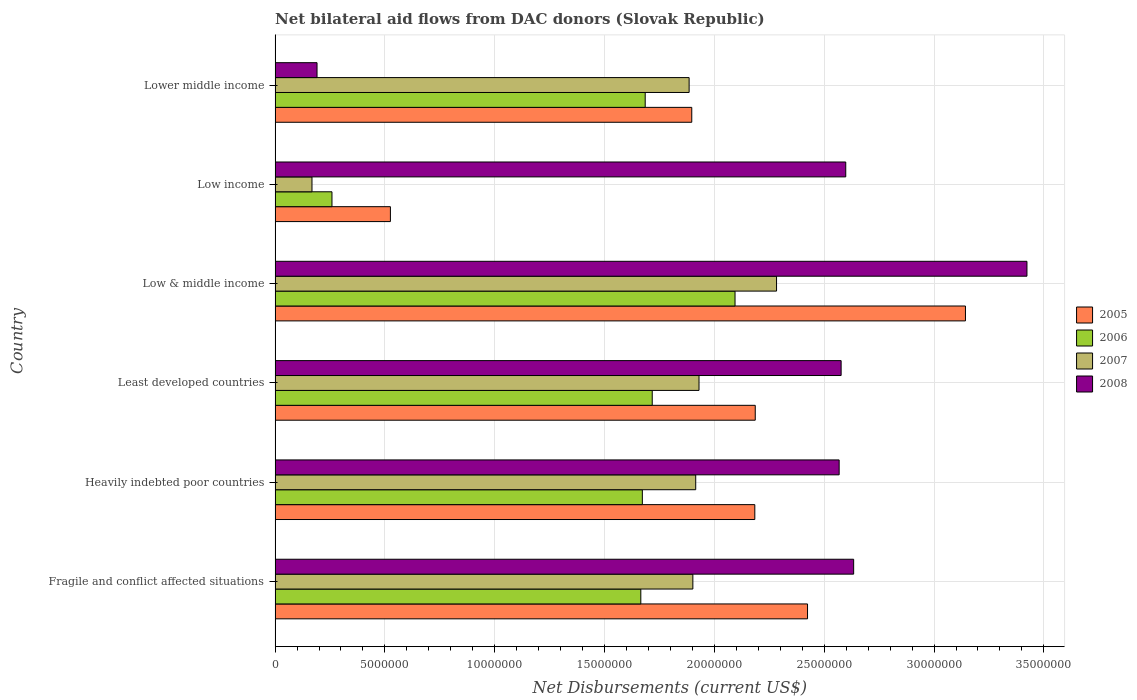How many groups of bars are there?
Give a very brief answer. 6. Are the number of bars on each tick of the Y-axis equal?
Keep it short and to the point. Yes. How many bars are there on the 6th tick from the top?
Offer a very short reply. 4. What is the label of the 4th group of bars from the top?
Offer a terse response. Least developed countries. What is the net bilateral aid flows in 2008 in Lower middle income?
Your answer should be very brief. 1.91e+06. Across all countries, what is the maximum net bilateral aid flows in 2006?
Offer a very short reply. 2.09e+07. Across all countries, what is the minimum net bilateral aid flows in 2005?
Make the answer very short. 5.25e+06. In which country was the net bilateral aid flows in 2006 maximum?
Keep it short and to the point. Low & middle income. In which country was the net bilateral aid flows in 2007 minimum?
Your response must be concise. Low income. What is the total net bilateral aid flows in 2008 in the graph?
Give a very brief answer. 1.40e+08. What is the difference between the net bilateral aid flows in 2007 in Heavily indebted poor countries and the net bilateral aid flows in 2008 in Lower middle income?
Offer a terse response. 1.72e+07. What is the average net bilateral aid flows in 2006 per country?
Give a very brief answer. 1.52e+07. What is the difference between the net bilateral aid flows in 2007 and net bilateral aid flows in 2005 in Least developed countries?
Provide a succinct answer. -2.56e+06. What is the ratio of the net bilateral aid flows in 2008 in Least developed countries to that in Low & middle income?
Your answer should be very brief. 0.75. Is the net bilateral aid flows in 2007 in Fragile and conflict affected situations less than that in Low & middle income?
Your answer should be compact. Yes. What is the difference between the highest and the second highest net bilateral aid flows in 2006?
Give a very brief answer. 3.77e+06. What is the difference between the highest and the lowest net bilateral aid flows in 2005?
Your answer should be compact. 2.62e+07. Is the sum of the net bilateral aid flows in 2006 in Fragile and conflict affected situations and Lower middle income greater than the maximum net bilateral aid flows in 2005 across all countries?
Your answer should be very brief. Yes. What does the 2nd bar from the bottom in Fragile and conflict affected situations represents?
Give a very brief answer. 2006. Is it the case that in every country, the sum of the net bilateral aid flows in 2005 and net bilateral aid flows in 2007 is greater than the net bilateral aid flows in 2008?
Provide a succinct answer. No. How many bars are there?
Make the answer very short. 24. Are all the bars in the graph horizontal?
Give a very brief answer. Yes. How many countries are there in the graph?
Your answer should be very brief. 6. What is the difference between two consecutive major ticks on the X-axis?
Ensure brevity in your answer.  5.00e+06. Are the values on the major ticks of X-axis written in scientific E-notation?
Your answer should be very brief. No. Does the graph contain grids?
Ensure brevity in your answer.  Yes. How many legend labels are there?
Make the answer very short. 4. What is the title of the graph?
Provide a succinct answer. Net bilateral aid flows from DAC donors (Slovak Republic). What is the label or title of the X-axis?
Make the answer very short. Net Disbursements (current US$). What is the Net Disbursements (current US$) of 2005 in Fragile and conflict affected situations?
Your answer should be compact. 2.42e+07. What is the Net Disbursements (current US$) of 2006 in Fragile and conflict affected situations?
Keep it short and to the point. 1.66e+07. What is the Net Disbursements (current US$) of 2007 in Fragile and conflict affected situations?
Your answer should be compact. 1.90e+07. What is the Net Disbursements (current US$) in 2008 in Fragile and conflict affected situations?
Your response must be concise. 2.63e+07. What is the Net Disbursements (current US$) of 2005 in Heavily indebted poor countries?
Your answer should be very brief. 2.18e+07. What is the Net Disbursements (current US$) in 2006 in Heavily indebted poor countries?
Offer a terse response. 1.67e+07. What is the Net Disbursements (current US$) of 2007 in Heavily indebted poor countries?
Keep it short and to the point. 1.92e+07. What is the Net Disbursements (current US$) in 2008 in Heavily indebted poor countries?
Keep it short and to the point. 2.57e+07. What is the Net Disbursements (current US$) in 2005 in Least developed countries?
Make the answer very short. 2.19e+07. What is the Net Disbursements (current US$) of 2006 in Least developed countries?
Provide a short and direct response. 1.72e+07. What is the Net Disbursements (current US$) of 2007 in Least developed countries?
Provide a succinct answer. 1.93e+07. What is the Net Disbursements (current US$) in 2008 in Least developed countries?
Offer a terse response. 2.58e+07. What is the Net Disbursements (current US$) of 2005 in Low & middle income?
Your response must be concise. 3.14e+07. What is the Net Disbursements (current US$) in 2006 in Low & middle income?
Provide a succinct answer. 2.09e+07. What is the Net Disbursements (current US$) in 2007 in Low & middle income?
Make the answer very short. 2.28e+07. What is the Net Disbursements (current US$) of 2008 in Low & middle income?
Provide a succinct answer. 3.42e+07. What is the Net Disbursements (current US$) in 2005 in Low income?
Your response must be concise. 5.25e+06. What is the Net Disbursements (current US$) in 2006 in Low income?
Ensure brevity in your answer.  2.59e+06. What is the Net Disbursements (current US$) of 2007 in Low income?
Your response must be concise. 1.68e+06. What is the Net Disbursements (current US$) in 2008 in Low income?
Your response must be concise. 2.60e+07. What is the Net Disbursements (current US$) in 2005 in Lower middle income?
Make the answer very short. 1.90e+07. What is the Net Disbursements (current US$) in 2006 in Lower middle income?
Offer a very short reply. 1.68e+07. What is the Net Disbursements (current US$) in 2007 in Lower middle income?
Your answer should be very brief. 1.88e+07. What is the Net Disbursements (current US$) in 2008 in Lower middle income?
Give a very brief answer. 1.91e+06. Across all countries, what is the maximum Net Disbursements (current US$) of 2005?
Your answer should be compact. 3.14e+07. Across all countries, what is the maximum Net Disbursements (current US$) of 2006?
Give a very brief answer. 2.09e+07. Across all countries, what is the maximum Net Disbursements (current US$) in 2007?
Ensure brevity in your answer.  2.28e+07. Across all countries, what is the maximum Net Disbursements (current US$) of 2008?
Make the answer very short. 3.42e+07. Across all countries, what is the minimum Net Disbursements (current US$) in 2005?
Offer a terse response. 5.25e+06. Across all countries, what is the minimum Net Disbursements (current US$) in 2006?
Provide a short and direct response. 2.59e+06. Across all countries, what is the minimum Net Disbursements (current US$) of 2007?
Ensure brevity in your answer.  1.68e+06. Across all countries, what is the minimum Net Disbursements (current US$) of 2008?
Ensure brevity in your answer.  1.91e+06. What is the total Net Disbursements (current US$) of 2005 in the graph?
Provide a short and direct response. 1.24e+08. What is the total Net Disbursements (current US$) in 2006 in the graph?
Keep it short and to the point. 9.09e+07. What is the total Net Disbursements (current US$) in 2007 in the graph?
Your response must be concise. 1.01e+08. What is the total Net Disbursements (current US$) in 2008 in the graph?
Your answer should be compact. 1.40e+08. What is the difference between the Net Disbursements (current US$) of 2005 in Fragile and conflict affected situations and that in Heavily indebted poor countries?
Your answer should be compact. 2.40e+06. What is the difference between the Net Disbursements (current US$) in 2007 in Fragile and conflict affected situations and that in Heavily indebted poor countries?
Keep it short and to the point. -1.30e+05. What is the difference between the Net Disbursements (current US$) in 2005 in Fragile and conflict affected situations and that in Least developed countries?
Keep it short and to the point. 2.38e+06. What is the difference between the Net Disbursements (current US$) of 2006 in Fragile and conflict affected situations and that in Least developed countries?
Your response must be concise. -5.20e+05. What is the difference between the Net Disbursements (current US$) in 2007 in Fragile and conflict affected situations and that in Least developed countries?
Make the answer very short. -2.80e+05. What is the difference between the Net Disbursements (current US$) in 2008 in Fragile and conflict affected situations and that in Least developed countries?
Your answer should be compact. 5.70e+05. What is the difference between the Net Disbursements (current US$) in 2005 in Fragile and conflict affected situations and that in Low & middle income?
Give a very brief answer. -7.19e+06. What is the difference between the Net Disbursements (current US$) of 2006 in Fragile and conflict affected situations and that in Low & middle income?
Ensure brevity in your answer.  -4.29e+06. What is the difference between the Net Disbursements (current US$) of 2007 in Fragile and conflict affected situations and that in Low & middle income?
Your answer should be very brief. -3.81e+06. What is the difference between the Net Disbursements (current US$) in 2008 in Fragile and conflict affected situations and that in Low & middle income?
Make the answer very short. -7.89e+06. What is the difference between the Net Disbursements (current US$) in 2005 in Fragile and conflict affected situations and that in Low income?
Make the answer very short. 1.90e+07. What is the difference between the Net Disbursements (current US$) in 2006 in Fragile and conflict affected situations and that in Low income?
Keep it short and to the point. 1.41e+07. What is the difference between the Net Disbursements (current US$) in 2007 in Fragile and conflict affected situations and that in Low income?
Provide a short and direct response. 1.73e+07. What is the difference between the Net Disbursements (current US$) in 2005 in Fragile and conflict affected situations and that in Lower middle income?
Ensure brevity in your answer.  5.27e+06. What is the difference between the Net Disbursements (current US$) of 2007 in Fragile and conflict affected situations and that in Lower middle income?
Provide a short and direct response. 1.70e+05. What is the difference between the Net Disbursements (current US$) of 2008 in Fragile and conflict affected situations and that in Lower middle income?
Provide a succinct answer. 2.44e+07. What is the difference between the Net Disbursements (current US$) in 2006 in Heavily indebted poor countries and that in Least developed countries?
Your response must be concise. -4.50e+05. What is the difference between the Net Disbursements (current US$) in 2007 in Heavily indebted poor countries and that in Least developed countries?
Keep it short and to the point. -1.50e+05. What is the difference between the Net Disbursements (current US$) of 2008 in Heavily indebted poor countries and that in Least developed countries?
Your answer should be very brief. -9.00e+04. What is the difference between the Net Disbursements (current US$) of 2005 in Heavily indebted poor countries and that in Low & middle income?
Offer a terse response. -9.59e+06. What is the difference between the Net Disbursements (current US$) of 2006 in Heavily indebted poor countries and that in Low & middle income?
Ensure brevity in your answer.  -4.22e+06. What is the difference between the Net Disbursements (current US$) in 2007 in Heavily indebted poor countries and that in Low & middle income?
Your answer should be very brief. -3.68e+06. What is the difference between the Net Disbursements (current US$) of 2008 in Heavily indebted poor countries and that in Low & middle income?
Make the answer very short. -8.55e+06. What is the difference between the Net Disbursements (current US$) in 2005 in Heavily indebted poor countries and that in Low income?
Make the answer very short. 1.66e+07. What is the difference between the Net Disbursements (current US$) of 2006 in Heavily indebted poor countries and that in Low income?
Keep it short and to the point. 1.41e+07. What is the difference between the Net Disbursements (current US$) of 2007 in Heavily indebted poor countries and that in Low income?
Provide a short and direct response. 1.75e+07. What is the difference between the Net Disbursements (current US$) in 2005 in Heavily indebted poor countries and that in Lower middle income?
Ensure brevity in your answer.  2.87e+06. What is the difference between the Net Disbursements (current US$) in 2006 in Heavily indebted poor countries and that in Lower middle income?
Provide a short and direct response. -1.30e+05. What is the difference between the Net Disbursements (current US$) in 2008 in Heavily indebted poor countries and that in Lower middle income?
Ensure brevity in your answer.  2.38e+07. What is the difference between the Net Disbursements (current US$) of 2005 in Least developed countries and that in Low & middle income?
Your response must be concise. -9.57e+06. What is the difference between the Net Disbursements (current US$) in 2006 in Least developed countries and that in Low & middle income?
Keep it short and to the point. -3.77e+06. What is the difference between the Net Disbursements (current US$) of 2007 in Least developed countries and that in Low & middle income?
Your answer should be very brief. -3.53e+06. What is the difference between the Net Disbursements (current US$) in 2008 in Least developed countries and that in Low & middle income?
Your answer should be compact. -8.46e+06. What is the difference between the Net Disbursements (current US$) of 2005 in Least developed countries and that in Low income?
Your response must be concise. 1.66e+07. What is the difference between the Net Disbursements (current US$) of 2006 in Least developed countries and that in Low income?
Your response must be concise. 1.46e+07. What is the difference between the Net Disbursements (current US$) in 2007 in Least developed countries and that in Low income?
Provide a short and direct response. 1.76e+07. What is the difference between the Net Disbursements (current US$) of 2008 in Least developed countries and that in Low income?
Ensure brevity in your answer.  -2.10e+05. What is the difference between the Net Disbursements (current US$) in 2005 in Least developed countries and that in Lower middle income?
Offer a terse response. 2.89e+06. What is the difference between the Net Disbursements (current US$) of 2006 in Least developed countries and that in Lower middle income?
Offer a very short reply. 3.20e+05. What is the difference between the Net Disbursements (current US$) in 2008 in Least developed countries and that in Lower middle income?
Your response must be concise. 2.39e+07. What is the difference between the Net Disbursements (current US$) in 2005 in Low & middle income and that in Low income?
Make the answer very short. 2.62e+07. What is the difference between the Net Disbursements (current US$) of 2006 in Low & middle income and that in Low income?
Your response must be concise. 1.84e+07. What is the difference between the Net Disbursements (current US$) in 2007 in Low & middle income and that in Low income?
Your answer should be compact. 2.12e+07. What is the difference between the Net Disbursements (current US$) in 2008 in Low & middle income and that in Low income?
Provide a succinct answer. 8.25e+06. What is the difference between the Net Disbursements (current US$) in 2005 in Low & middle income and that in Lower middle income?
Ensure brevity in your answer.  1.25e+07. What is the difference between the Net Disbursements (current US$) in 2006 in Low & middle income and that in Lower middle income?
Offer a very short reply. 4.09e+06. What is the difference between the Net Disbursements (current US$) in 2007 in Low & middle income and that in Lower middle income?
Your answer should be compact. 3.98e+06. What is the difference between the Net Disbursements (current US$) of 2008 in Low & middle income and that in Lower middle income?
Give a very brief answer. 3.23e+07. What is the difference between the Net Disbursements (current US$) in 2005 in Low income and that in Lower middle income?
Provide a succinct answer. -1.37e+07. What is the difference between the Net Disbursements (current US$) of 2006 in Low income and that in Lower middle income?
Ensure brevity in your answer.  -1.43e+07. What is the difference between the Net Disbursements (current US$) in 2007 in Low income and that in Lower middle income?
Offer a very short reply. -1.72e+07. What is the difference between the Net Disbursements (current US$) in 2008 in Low income and that in Lower middle income?
Your response must be concise. 2.41e+07. What is the difference between the Net Disbursements (current US$) of 2005 in Fragile and conflict affected situations and the Net Disbursements (current US$) of 2006 in Heavily indebted poor countries?
Offer a very short reply. 7.52e+06. What is the difference between the Net Disbursements (current US$) in 2005 in Fragile and conflict affected situations and the Net Disbursements (current US$) in 2007 in Heavily indebted poor countries?
Offer a very short reply. 5.09e+06. What is the difference between the Net Disbursements (current US$) in 2005 in Fragile and conflict affected situations and the Net Disbursements (current US$) in 2008 in Heavily indebted poor countries?
Make the answer very short. -1.44e+06. What is the difference between the Net Disbursements (current US$) in 2006 in Fragile and conflict affected situations and the Net Disbursements (current US$) in 2007 in Heavily indebted poor countries?
Your answer should be compact. -2.50e+06. What is the difference between the Net Disbursements (current US$) in 2006 in Fragile and conflict affected situations and the Net Disbursements (current US$) in 2008 in Heavily indebted poor countries?
Make the answer very short. -9.03e+06. What is the difference between the Net Disbursements (current US$) in 2007 in Fragile and conflict affected situations and the Net Disbursements (current US$) in 2008 in Heavily indebted poor countries?
Your answer should be very brief. -6.66e+06. What is the difference between the Net Disbursements (current US$) of 2005 in Fragile and conflict affected situations and the Net Disbursements (current US$) of 2006 in Least developed countries?
Your response must be concise. 7.07e+06. What is the difference between the Net Disbursements (current US$) in 2005 in Fragile and conflict affected situations and the Net Disbursements (current US$) in 2007 in Least developed countries?
Make the answer very short. 4.94e+06. What is the difference between the Net Disbursements (current US$) of 2005 in Fragile and conflict affected situations and the Net Disbursements (current US$) of 2008 in Least developed countries?
Make the answer very short. -1.53e+06. What is the difference between the Net Disbursements (current US$) in 2006 in Fragile and conflict affected situations and the Net Disbursements (current US$) in 2007 in Least developed countries?
Provide a short and direct response. -2.65e+06. What is the difference between the Net Disbursements (current US$) of 2006 in Fragile and conflict affected situations and the Net Disbursements (current US$) of 2008 in Least developed countries?
Provide a short and direct response. -9.12e+06. What is the difference between the Net Disbursements (current US$) in 2007 in Fragile and conflict affected situations and the Net Disbursements (current US$) in 2008 in Least developed countries?
Ensure brevity in your answer.  -6.75e+06. What is the difference between the Net Disbursements (current US$) of 2005 in Fragile and conflict affected situations and the Net Disbursements (current US$) of 2006 in Low & middle income?
Your response must be concise. 3.30e+06. What is the difference between the Net Disbursements (current US$) in 2005 in Fragile and conflict affected situations and the Net Disbursements (current US$) in 2007 in Low & middle income?
Give a very brief answer. 1.41e+06. What is the difference between the Net Disbursements (current US$) of 2005 in Fragile and conflict affected situations and the Net Disbursements (current US$) of 2008 in Low & middle income?
Make the answer very short. -9.99e+06. What is the difference between the Net Disbursements (current US$) in 2006 in Fragile and conflict affected situations and the Net Disbursements (current US$) in 2007 in Low & middle income?
Your response must be concise. -6.18e+06. What is the difference between the Net Disbursements (current US$) in 2006 in Fragile and conflict affected situations and the Net Disbursements (current US$) in 2008 in Low & middle income?
Ensure brevity in your answer.  -1.76e+07. What is the difference between the Net Disbursements (current US$) of 2007 in Fragile and conflict affected situations and the Net Disbursements (current US$) of 2008 in Low & middle income?
Your answer should be very brief. -1.52e+07. What is the difference between the Net Disbursements (current US$) in 2005 in Fragile and conflict affected situations and the Net Disbursements (current US$) in 2006 in Low income?
Your answer should be compact. 2.16e+07. What is the difference between the Net Disbursements (current US$) of 2005 in Fragile and conflict affected situations and the Net Disbursements (current US$) of 2007 in Low income?
Your response must be concise. 2.26e+07. What is the difference between the Net Disbursements (current US$) in 2005 in Fragile and conflict affected situations and the Net Disbursements (current US$) in 2008 in Low income?
Your answer should be very brief. -1.74e+06. What is the difference between the Net Disbursements (current US$) in 2006 in Fragile and conflict affected situations and the Net Disbursements (current US$) in 2007 in Low income?
Your answer should be compact. 1.50e+07. What is the difference between the Net Disbursements (current US$) in 2006 in Fragile and conflict affected situations and the Net Disbursements (current US$) in 2008 in Low income?
Provide a short and direct response. -9.33e+06. What is the difference between the Net Disbursements (current US$) in 2007 in Fragile and conflict affected situations and the Net Disbursements (current US$) in 2008 in Low income?
Give a very brief answer. -6.96e+06. What is the difference between the Net Disbursements (current US$) in 2005 in Fragile and conflict affected situations and the Net Disbursements (current US$) in 2006 in Lower middle income?
Offer a terse response. 7.39e+06. What is the difference between the Net Disbursements (current US$) in 2005 in Fragile and conflict affected situations and the Net Disbursements (current US$) in 2007 in Lower middle income?
Ensure brevity in your answer.  5.39e+06. What is the difference between the Net Disbursements (current US$) in 2005 in Fragile and conflict affected situations and the Net Disbursements (current US$) in 2008 in Lower middle income?
Provide a succinct answer. 2.23e+07. What is the difference between the Net Disbursements (current US$) of 2006 in Fragile and conflict affected situations and the Net Disbursements (current US$) of 2007 in Lower middle income?
Provide a short and direct response. -2.20e+06. What is the difference between the Net Disbursements (current US$) of 2006 in Fragile and conflict affected situations and the Net Disbursements (current US$) of 2008 in Lower middle income?
Your answer should be compact. 1.47e+07. What is the difference between the Net Disbursements (current US$) of 2007 in Fragile and conflict affected situations and the Net Disbursements (current US$) of 2008 in Lower middle income?
Give a very brief answer. 1.71e+07. What is the difference between the Net Disbursements (current US$) in 2005 in Heavily indebted poor countries and the Net Disbursements (current US$) in 2006 in Least developed countries?
Make the answer very short. 4.67e+06. What is the difference between the Net Disbursements (current US$) in 2005 in Heavily indebted poor countries and the Net Disbursements (current US$) in 2007 in Least developed countries?
Your answer should be very brief. 2.54e+06. What is the difference between the Net Disbursements (current US$) in 2005 in Heavily indebted poor countries and the Net Disbursements (current US$) in 2008 in Least developed countries?
Your answer should be compact. -3.93e+06. What is the difference between the Net Disbursements (current US$) of 2006 in Heavily indebted poor countries and the Net Disbursements (current US$) of 2007 in Least developed countries?
Make the answer very short. -2.58e+06. What is the difference between the Net Disbursements (current US$) in 2006 in Heavily indebted poor countries and the Net Disbursements (current US$) in 2008 in Least developed countries?
Offer a very short reply. -9.05e+06. What is the difference between the Net Disbursements (current US$) of 2007 in Heavily indebted poor countries and the Net Disbursements (current US$) of 2008 in Least developed countries?
Provide a short and direct response. -6.62e+06. What is the difference between the Net Disbursements (current US$) in 2005 in Heavily indebted poor countries and the Net Disbursements (current US$) in 2006 in Low & middle income?
Provide a succinct answer. 9.00e+05. What is the difference between the Net Disbursements (current US$) of 2005 in Heavily indebted poor countries and the Net Disbursements (current US$) of 2007 in Low & middle income?
Your answer should be compact. -9.90e+05. What is the difference between the Net Disbursements (current US$) of 2005 in Heavily indebted poor countries and the Net Disbursements (current US$) of 2008 in Low & middle income?
Give a very brief answer. -1.24e+07. What is the difference between the Net Disbursements (current US$) in 2006 in Heavily indebted poor countries and the Net Disbursements (current US$) in 2007 in Low & middle income?
Your response must be concise. -6.11e+06. What is the difference between the Net Disbursements (current US$) in 2006 in Heavily indebted poor countries and the Net Disbursements (current US$) in 2008 in Low & middle income?
Keep it short and to the point. -1.75e+07. What is the difference between the Net Disbursements (current US$) in 2007 in Heavily indebted poor countries and the Net Disbursements (current US$) in 2008 in Low & middle income?
Ensure brevity in your answer.  -1.51e+07. What is the difference between the Net Disbursements (current US$) in 2005 in Heavily indebted poor countries and the Net Disbursements (current US$) in 2006 in Low income?
Keep it short and to the point. 1.92e+07. What is the difference between the Net Disbursements (current US$) in 2005 in Heavily indebted poor countries and the Net Disbursements (current US$) in 2007 in Low income?
Keep it short and to the point. 2.02e+07. What is the difference between the Net Disbursements (current US$) of 2005 in Heavily indebted poor countries and the Net Disbursements (current US$) of 2008 in Low income?
Offer a terse response. -4.14e+06. What is the difference between the Net Disbursements (current US$) of 2006 in Heavily indebted poor countries and the Net Disbursements (current US$) of 2007 in Low income?
Provide a short and direct response. 1.50e+07. What is the difference between the Net Disbursements (current US$) in 2006 in Heavily indebted poor countries and the Net Disbursements (current US$) in 2008 in Low income?
Give a very brief answer. -9.26e+06. What is the difference between the Net Disbursements (current US$) of 2007 in Heavily indebted poor countries and the Net Disbursements (current US$) of 2008 in Low income?
Your answer should be compact. -6.83e+06. What is the difference between the Net Disbursements (current US$) in 2005 in Heavily indebted poor countries and the Net Disbursements (current US$) in 2006 in Lower middle income?
Provide a short and direct response. 4.99e+06. What is the difference between the Net Disbursements (current US$) of 2005 in Heavily indebted poor countries and the Net Disbursements (current US$) of 2007 in Lower middle income?
Give a very brief answer. 2.99e+06. What is the difference between the Net Disbursements (current US$) of 2005 in Heavily indebted poor countries and the Net Disbursements (current US$) of 2008 in Lower middle income?
Your answer should be very brief. 1.99e+07. What is the difference between the Net Disbursements (current US$) of 2006 in Heavily indebted poor countries and the Net Disbursements (current US$) of 2007 in Lower middle income?
Give a very brief answer. -2.13e+06. What is the difference between the Net Disbursements (current US$) of 2006 in Heavily indebted poor countries and the Net Disbursements (current US$) of 2008 in Lower middle income?
Provide a short and direct response. 1.48e+07. What is the difference between the Net Disbursements (current US$) in 2007 in Heavily indebted poor countries and the Net Disbursements (current US$) in 2008 in Lower middle income?
Your response must be concise. 1.72e+07. What is the difference between the Net Disbursements (current US$) of 2005 in Least developed countries and the Net Disbursements (current US$) of 2006 in Low & middle income?
Your answer should be compact. 9.20e+05. What is the difference between the Net Disbursements (current US$) in 2005 in Least developed countries and the Net Disbursements (current US$) in 2007 in Low & middle income?
Offer a very short reply. -9.70e+05. What is the difference between the Net Disbursements (current US$) of 2005 in Least developed countries and the Net Disbursements (current US$) of 2008 in Low & middle income?
Provide a short and direct response. -1.24e+07. What is the difference between the Net Disbursements (current US$) of 2006 in Least developed countries and the Net Disbursements (current US$) of 2007 in Low & middle income?
Your answer should be compact. -5.66e+06. What is the difference between the Net Disbursements (current US$) in 2006 in Least developed countries and the Net Disbursements (current US$) in 2008 in Low & middle income?
Your answer should be very brief. -1.71e+07. What is the difference between the Net Disbursements (current US$) of 2007 in Least developed countries and the Net Disbursements (current US$) of 2008 in Low & middle income?
Your response must be concise. -1.49e+07. What is the difference between the Net Disbursements (current US$) of 2005 in Least developed countries and the Net Disbursements (current US$) of 2006 in Low income?
Your answer should be very brief. 1.93e+07. What is the difference between the Net Disbursements (current US$) of 2005 in Least developed countries and the Net Disbursements (current US$) of 2007 in Low income?
Provide a short and direct response. 2.02e+07. What is the difference between the Net Disbursements (current US$) in 2005 in Least developed countries and the Net Disbursements (current US$) in 2008 in Low income?
Your answer should be compact. -4.12e+06. What is the difference between the Net Disbursements (current US$) in 2006 in Least developed countries and the Net Disbursements (current US$) in 2007 in Low income?
Keep it short and to the point. 1.55e+07. What is the difference between the Net Disbursements (current US$) of 2006 in Least developed countries and the Net Disbursements (current US$) of 2008 in Low income?
Ensure brevity in your answer.  -8.81e+06. What is the difference between the Net Disbursements (current US$) in 2007 in Least developed countries and the Net Disbursements (current US$) in 2008 in Low income?
Provide a short and direct response. -6.68e+06. What is the difference between the Net Disbursements (current US$) of 2005 in Least developed countries and the Net Disbursements (current US$) of 2006 in Lower middle income?
Give a very brief answer. 5.01e+06. What is the difference between the Net Disbursements (current US$) in 2005 in Least developed countries and the Net Disbursements (current US$) in 2007 in Lower middle income?
Your answer should be very brief. 3.01e+06. What is the difference between the Net Disbursements (current US$) in 2005 in Least developed countries and the Net Disbursements (current US$) in 2008 in Lower middle income?
Your answer should be very brief. 2.00e+07. What is the difference between the Net Disbursements (current US$) in 2006 in Least developed countries and the Net Disbursements (current US$) in 2007 in Lower middle income?
Ensure brevity in your answer.  -1.68e+06. What is the difference between the Net Disbursements (current US$) in 2006 in Least developed countries and the Net Disbursements (current US$) in 2008 in Lower middle income?
Your answer should be compact. 1.53e+07. What is the difference between the Net Disbursements (current US$) in 2007 in Least developed countries and the Net Disbursements (current US$) in 2008 in Lower middle income?
Provide a succinct answer. 1.74e+07. What is the difference between the Net Disbursements (current US$) in 2005 in Low & middle income and the Net Disbursements (current US$) in 2006 in Low income?
Your response must be concise. 2.88e+07. What is the difference between the Net Disbursements (current US$) in 2005 in Low & middle income and the Net Disbursements (current US$) in 2007 in Low income?
Provide a succinct answer. 2.98e+07. What is the difference between the Net Disbursements (current US$) of 2005 in Low & middle income and the Net Disbursements (current US$) of 2008 in Low income?
Your answer should be compact. 5.45e+06. What is the difference between the Net Disbursements (current US$) in 2006 in Low & middle income and the Net Disbursements (current US$) in 2007 in Low income?
Your answer should be compact. 1.93e+07. What is the difference between the Net Disbursements (current US$) of 2006 in Low & middle income and the Net Disbursements (current US$) of 2008 in Low income?
Your response must be concise. -5.04e+06. What is the difference between the Net Disbursements (current US$) of 2007 in Low & middle income and the Net Disbursements (current US$) of 2008 in Low income?
Your response must be concise. -3.15e+06. What is the difference between the Net Disbursements (current US$) in 2005 in Low & middle income and the Net Disbursements (current US$) in 2006 in Lower middle income?
Give a very brief answer. 1.46e+07. What is the difference between the Net Disbursements (current US$) in 2005 in Low & middle income and the Net Disbursements (current US$) in 2007 in Lower middle income?
Provide a succinct answer. 1.26e+07. What is the difference between the Net Disbursements (current US$) of 2005 in Low & middle income and the Net Disbursements (current US$) of 2008 in Lower middle income?
Your answer should be compact. 2.95e+07. What is the difference between the Net Disbursements (current US$) in 2006 in Low & middle income and the Net Disbursements (current US$) in 2007 in Lower middle income?
Provide a short and direct response. 2.09e+06. What is the difference between the Net Disbursements (current US$) in 2006 in Low & middle income and the Net Disbursements (current US$) in 2008 in Lower middle income?
Give a very brief answer. 1.90e+07. What is the difference between the Net Disbursements (current US$) of 2007 in Low & middle income and the Net Disbursements (current US$) of 2008 in Lower middle income?
Give a very brief answer. 2.09e+07. What is the difference between the Net Disbursements (current US$) in 2005 in Low income and the Net Disbursements (current US$) in 2006 in Lower middle income?
Offer a terse response. -1.16e+07. What is the difference between the Net Disbursements (current US$) in 2005 in Low income and the Net Disbursements (current US$) in 2007 in Lower middle income?
Your response must be concise. -1.36e+07. What is the difference between the Net Disbursements (current US$) in 2005 in Low income and the Net Disbursements (current US$) in 2008 in Lower middle income?
Keep it short and to the point. 3.34e+06. What is the difference between the Net Disbursements (current US$) in 2006 in Low income and the Net Disbursements (current US$) in 2007 in Lower middle income?
Provide a succinct answer. -1.63e+07. What is the difference between the Net Disbursements (current US$) of 2006 in Low income and the Net Disbursements (current US$) of 2008 in Lower middle income?
Offer a terse response. 6.80e+05. What is the average Net Disbursements (current US$) of 2005 per country?
Provide a succinct answer. 2.06e+07. What is the average Net Disbursements (current US$) of 2006 per country?
Your response must be concise. 1.52e+07. What is the average Net Disbursements (current US$) of 2007 per country?
Your response must be concise. 1.68e+07. What is the average Net Disbursements (current US$) in 2008 per country?
Provide a short and direct response. 2.33e+07. What is the difference between the Net Disbursements (current US$) in 2005 and Net Disbursements (current US$) in 2006 in Fragile and conflict affected situations?
Ensure brevity in your answer.  7.59e+06. What is the difference between the Net Disbursements (current US$) in 2005 and Net Disbursements (current US$) in 2007 in Fragile and conflict affected situations?
Your response must be concise. 5.22e+06. What is the difference between the Net Disbursements (current US$) of 2005 and Net Disbursements (current US$) of 2008 in Fragile and conflict affected situations?
Make the answer very short. -2.10e+06. What is the difference between the Net Disbursements (current US$) of 2006 and Net Disbursements (current US$) of 2007 in Fragile and conflict affected situations?
Ensure brevity in your answer.  -2.37e+06. What is the difference between the Net Disbursements (current US$) in 2006 and Net Disbursements (current US$) in 2008 in Fragile and conflict affected situations?
Make the answer very short. -9.69e+06. What is the difference between the Net Disbursements (current US$) in 2007 and Net Disbursements (current US$) in 2008 in Fragile and conflict affected situations?
Provide a short and direct response. -7.32e+06. What is the difference between the Net Disbursements (current US$) in 2005 and Net Disbursements (current US$) in 2006 in Heavily indebted poor countries?
Make the answer very short. 5.12e+06. What is the difference between the Net Disbursements (current US$) of 2005 and Net Disbursements (current US$) of 2007 in Heavily indebted poor countries?
Ensure brevity in your answer.  2.69e+06. What is the difference between the Net Disbursements (current US$) of 2005 and Net Disbursements (current US$) of 2008 in Heavily indebted poor countries?
Offer a very short reply. -3.84e+06. What is the difference between the Net Disbursements (current US$) of 2006 and Net Disbursements (current US$) of 2007 in Heavily indebted poor countries?
Provide a short and direct response. -2.43e+06. What is the difference between the Net Disbursements (current US$) of 2006 and Net Disbursements (current US$) of 2008 in Heavily indebted poor countries?
Ensure brevity in your answer.  -8.96e+06. What is the difference between the Net Disbursements (current US$) of 2007 and Net Disbursements (current US$) of 2008 in Heavily indebted poor countries?
Your answer should be very brief. -6.53e+06. What is the difference between the Net Disbursements (current US$) of 2005 and Net Disbursements (current US$) of 2006 in Least developed countries?
Give a very brief answer. 4.69e+06. What is the difference between the Net Disbursements (current US$) of 2005 and Net Disbursements (current US$) of 2007 in Least developed countries?
Offer a terse response. 2.56e+06. What is the difference between the Net Disbursements (current US$) in 2005 and Net Disbursements (current US$) in 2008 in Least developed countries?
Your answer should be very brief. -3.91e+06. What is the difference between the Net Disbursements (current US$) in 2006 and Net Disbursements (current US$) in 2007 in Least developed countries?
Keep it short and to the point. -2.13e+06. What is the difference between the Net Disbursements (current US$) in 2006 and Net Disbursements (current US$) in 2008 in Least developed countries?
Provide a short and direct response. -8.60e+06. What is the difference between the Net Disbursements (current US$) in 2007 and Net Disbursements (current US$) in 2008 in Least developed countries?
Ensure brevity in your answer.  -6.47e+06. What is the difference between the Net Disbursements (current US$) of 2005 and Net Disbursements (current US$) of 2006 in Low & middle income?
Ensure brevity in your answer.  1.05e+07. What is the difference between the Net Disbursements (current US$) of 2005 and Net Disbursements (current US$) of 2007 in Low & middle income?
Make the answer very short. 8.60e+06. What is the difference between the Net Disbursements (current US$) in 2005 and Net Disbursements (current US$) in 2008 in Low & middle income?
Provide a succinct answer. -2.80e+06. What is the difference between the Net Disbursements (current US$) in 2006 and Net Disbursements (current US$) in 2007 in Low & middle income?
Ensure brevity in your answer.  -1.89e+06. What is the difference between the Net Disbursements (current US$) of 2006 and Net Disbursements (current US$) of 2008 in Low & middle income?
Ensure brevity in your answer.  -1.33e+07. What is the difference between the Net Disbursements (current US$) in 2007 and Net Disbursements (current US$) in 2008 in Low & middle income?
Ensure brevity in your answer.  -1.14e+07. What is the difference between the Net Disbursements (current US$) in 2005 and Net Disbursements (current US$) in 2006 in Low income?
Your answer should be compact. 2.66e+06. What is the difference between the Net Disbursements (current US$) of 2005 and Net Disbursements (current US$) of 2007 in Low income?
Provide a short and direct response. 3.57e+06. What is the difference between the Net Disbursements (current US$) in 2005 and Net Disbursements (current US$) in 2008 in Low income?
Ensure brevity in your answer.  -2.07e+07. What is the difference between the Net Disbursements (current US$) in 2006 and Net Disbursements (current US$) in 2007 in Low income?
Offer a terse response. 9.10e+05. What is the difference between the Net Disbursements (current US$) in 2006 and Net Disbursements (current US$) in 2008 in Low income?
Your answer should be compact. -2.34e+07. What is the difference between the Net Disbursements (current US$) of 2007 and Net Disbursements (current US$) of 2008 in Low income?
Give a very brief answer. -2.43e+07. What is the difference between the Net Disbursements (current US$) of 2005 and Net Disbursements (current US$) of 2006 in Lower middle income?
Offer a very short reply. 2.12e+06. What is the difference between the Net Disbursements (current US$) of 2005 and Net Disbursements (current US$) of 2008 in Lower middle income?
Your answer should be compact. 1.71e+07. What is the difference between the Net Disbursements (current US$) of 2006 and Net Disbursements (current US$) of 2008 in Lower middle income?
Your answer should be compact. 1.49e+07. What is the difference between the Net Disbursements (current US$) in 2007 and Net Disbursements (current US$) in 2008 in Lower middle income?
Offer a very short reply. 1.69e+07. What is the ratio of the Net Disbursements (current US$) of 2005 in Fragile and conflict affected situations to that in Heavily indebted poor countries?
Your response must be concise. 1.11. What is the ratio of the Net Disbursements (current US$) in 2007 in Fragile and conflict affected situations to that in Heavily indebted poor countries?
Your answer should be very brief. 0.99. What is the ratio of the Net Disbursements (current US$) in 2008 in Fragile and conflict affected situations to that in Heavily indebted poor countries?
Your answer should be very brief. 1.03. What is the ratio of the Net Disbursements (current US$) in 2005 in Fragile and conflict affected situations to that in Least developed countries?
Your response must be concise. 1.11. What is the ratio of the Net Disbursements (current US$) of 2006 in Fragile and conflict affected situations to that in Least developed countries?
Provide a short and direct response. 0.97. What is the ratio of the Net Disbursements (current US$) of 2007 in Fragile and conflict affected situations to that in Least developed countries?
Provide a succinct answer. 0.99. What is the ratio of the Net Disbursements (current US$) of 2008 in Fragile and conflict affected situations to that in Least developed countries?
Your answer should be very brief. 1.02. What is the ratio of the Net Disbursements (current US$) of 2005 in Fragile and conflict affected situations to that in Low & middle income?
Give a very brief answer. 0.77. What is the ratio of the Net Disbursements (current US$) in 2006 in Fragile and conflict affected situations to that in Low & middle income?
Offer a terse response. 0.8. What is the ratio of the Net Disbursements (current US$) of 2007 in Fragile and conflict affected situations to that in Low & middle income?
Give a very brief answer. 0.83. What is the ratio of the Net Disbursements (current US$) in 2008 in Fragile and conflict affected situations to that in Low & middle income?
Make the answer very short. 0.77. What is the ratio of the Net Disbursements (current US$) of 2005 in Fragile and conflict affected situations to that in Low income?
Make the answer very short. 4.62. What is the ratio of the Net Disbursements (current US$) in 2006 in Fragile and conflict affected situations to that in Low income?
Provide a short and direct response. 6.43. What is the ratio of the Net Disbursements (current US$) of 2007 in Fragile and conflict affected situations to that in Low income?
Offer a very short reply. 11.32. What is the ratio of the Net Disbursements (current US$) in 2008 in Fragile and conflict affected situations to that in Low income?
Offer a terse response. 1.01. What is the ratio of the Net Disbursements (current US$) of 2005 in Fragile and conflict affected situations to that in Lower middle income?
Keep it short and to the point. 1.28. What is the ratio of the Net Disbursements (current US$) in 2008 in Fragile and conflict affected situations to that in Lower middle income?
Ensure brevity in your answer.  13.79. What is the ratio of the Net Disbursements (current US$) of 2005 in Heavily indebted poor countries to that in Least developed countries?
Your answer should be compact. 1. What is the ratio of the Net Disbursements (current US$) in 2006 in Heavily indebted poor countries to that in Least developed countries?
Provide a short and direct response. 0.97. What is the ratio of the Net Disbursements (current US$) in 2005 in Heavily indebted poor countries to that in Low & middle income?
Provide a succinct answer. 0.69. What is the ratio of the Net Disbursements (current US$) in 2006 in Heavily indebted poor countries to that in Low & middle income?
Make the answer very short. 0.8. What is the ratio of the Net Disbursements (current US$) of 2007 in Heavily indebted poor countries to that in Low & middle income?
Keep it short and to the point. 0.84. What is the ratio of the Net Disbursements (current US$) in 2008 in Heavily indebted poor countries to that in Low & middle income?
Make the answer very short. 0.75. What is the ratio of the Net Disbursements (current US$) in 2005 in Heavily indebted poor countries to that in Low income?
Your answer should be very brief. 4.16. What is the ratio of the Net Disbursements (current US$) in 2006 in Heavily indebted poor countries to that in Low income?
Offer a terse response. 6.46. What is the ratio of the Net Disbursements (current US$) of 2007 in Heavily indebted poor countries to that in Low income?
Provide a succinct answer. 11.4. What is the ratio of the Net Disbursements (current US$) of 2005 in Heavily indebted poor countries to that in Lower middle income?
Your answer should be very brief. 1.15. What is the ratio of the Net Disbursements (current US$) in 2006 in Heavily indebted poor countries to that in Lower middle income?
Offer a terse response. 0.99. What is the ratio of the Net Disbursements (current US$) of 2007 in Heavily indebted poor countries to that in Lower middle income?
Your answer should be compact. 1.02. What is the ratio of the Net Disbursements (current US$) in 2008 in Heavily indebted poor countries to that in Lower middle income?
Ensure brevity in your answer.  13.45. What is the ratio of the Net Disbursements (current US$) of 2005 in Least developed countries to that in Low & middle income?
Your answer should be very brief. 0.7. What is the ratio of the Net Disbursements (current US$) of 2006 in Least developed countries to that in Low & middle income?
Offer a terse response. 0.82. What is the ratio of the Net Disbursements (current US$) in 2007 in Least developed countries to that in Low & middle income?
Give a very brief answer. 0.85. What is the ratio of the Net Disbursements (current US$) of 2008 in Least developed countries to that in Low & middle income?
Offer a terse response. 0.75. What is the ratio of the Net Disbursements (current US$) in 2005 in Least developed countries to that in Low income?
Your answer should be compact. 4.16. What is the ratio of the Net Disbursements (current US$) of 2006 in Least developed countries to that in Low income?
Offer a very short reply. 6.63. What is the ratio of the Net Disbursements (current US$) of 2007 in Least developed countries to that in Low income?
Offer a very short reply. 11.49. What is the ratio of the Net Disbursements (current US$) of 2005 in Least developed countries to that in Lower middle income?
Your response must be concise. 1.15. What is the ratio of the Net Disbursements (current US$) of 2006 in Least developed countries to that in Lower middle income?
Keep it short and to the point. 1.02. What is the ratio of the Net Disbursements (current US$) in 2007 in Least developed countries to that in Lower middle income?
Your answer should be very brief. 1.02. What is the ratio of the Net Disbursements (current US$) of 2008 in Least developed countries to that in Lower middle income?
Make the answer very short. 13.49. What is the ratio of the Net Disbursements (current US$) of 2005 in Low & middle income to that in Low income?
Your answer should be compact. 5.99. What is the ratio of the Net Disbursements (current US$) in 2006 in Low & middle income to that in Low income?
Your answer should be very brief. 8.08. What is the ratio of the Net Disbursements (current US$) in 2007 in Low & middle income to that in Low income?
Ensure brevity in your answer.  13.59. What is the ratio of the Net Disbursements (current US$) in 2008 in Low & middle income to that in Low income?
Make the answer very short. 1.32. What is the ratio of the Net Disbursements (current US$) in 2005 in Low & middle income to that in Lower middle income?
Keep it short and to the point. 1.66. What is the ratio of the Net Disbursements (current US$) of 2006 in Low & middle income to that in Lower middle income?
Make the answer very short. 1.24. What is the ratio of the Net Disbursements (current US$) in 2007 in Low & middle income to that in Lower middle income?
Your response must be concise. 1.21. What is the ratio of the Net Disbursements (current US$) of 2008 in Low & middle income to that in Lower middle income?
Your response must be concise. 17.92. What is the ratio of the Net Disbursements (current US$) in 2005 in Low income to that in Lower middle income?
Your answer should be compact. 0.28. What is the ratio of the Net Disbursements (current US$) of 2006 in Low income to that in Lower middle income?
Provide a succinct answer. 0.15. What is the ratio of the Net Disbursements (current US$) in 2007 in Low income to that in Lower middle income?
Your response must be concise. 0.09. What is the ratio of the Net Disbursements (current US$) of 2008 in Low income to that in Lower middle income?
Your answer should be very brief. 13.6. What is the difference between the highest and the second highest Net Disbursements (current US$) in 2005?
Make the answer very short. 7.19e+06. What is the difference between the highest and the second highest Net Disbursements (current US$) in 2006?
Your response must be concise. 3.77e+06. What is the difference between the highest and the second highest Net Disbursements (current US$) of 2007?
Your answer should be very brief. 3.53e+06. What is the difference between the highest and the second highest Net Disbursements (current US$) in 2008?
Ensure brevity in your answer.  7.89e+06. What is the difference between the highest and the lowest Net Disbursements (current US$) in 2005?
Offer a terse response. 2.62e+07. What is the difference between the highest and the lowest Net Disbursements (current US$) of 2006?
Give a very brief answer. 1.84e+07. What is the difference between the highest and the lowest Net Disbursements (current US$) in 2007?
Ensure brevity in your answer.  2.12e+07. What is the difference between the highest and the lowest Net Disbursements (current US$) in 2008?
Your answer should be very brief. 3.23e+07. 